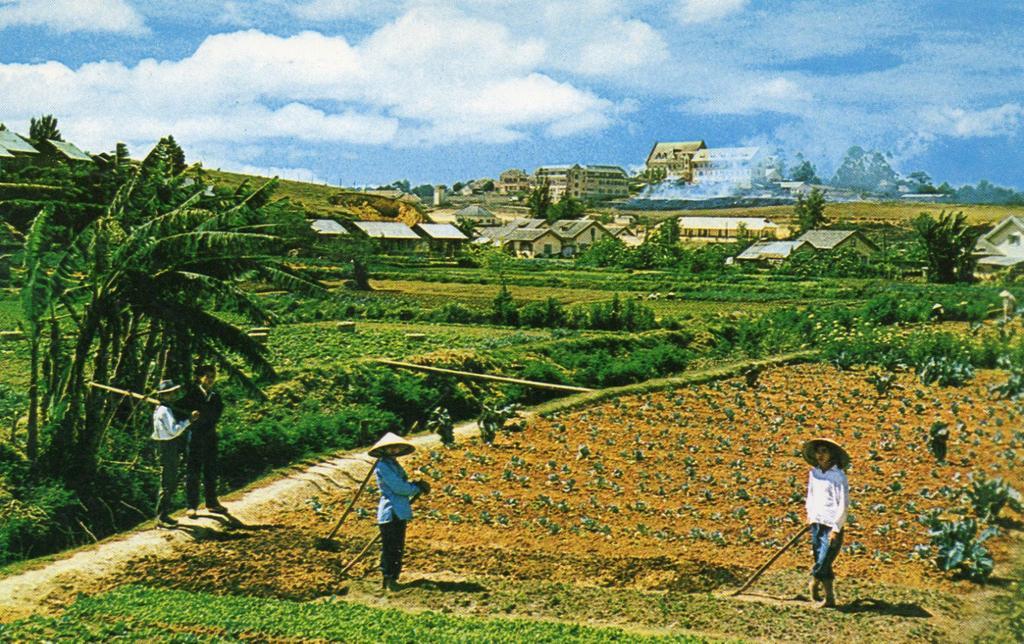Please provide a concise description of this image. This image is taken outdoors. At the top of the image there is the sky with clouds. At the bottom of the image there is a ground with grass on it. In the middle of the image there are many houses. There are many trees and plants with leaves, stems and branches. In the background there are two hills. In the middle of the image four people are standing on the ground and they are holding sticks in their hands. 